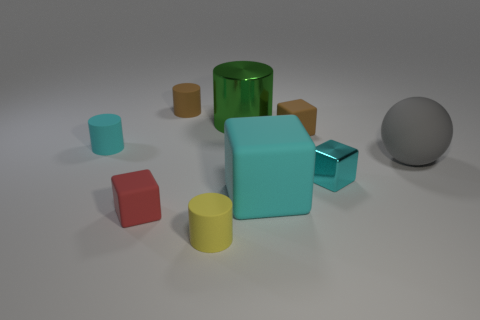Are any metal things visible?
Make the answer very short. Yes. What material is the small cylinder that is the same color as the small metal cube?
Ensure brevity in your answer.  Rubber. What number of objects are either tiny red matte cubes or metallic blocks?
Keep it short and to the point. 2. Is there a metal object that has the same color as the large cylinder?
Ensure brevity in your answer.  No. There is a cyan thing that is behind the ball; how many red blocks are to the left of it?
Ensure brevity in your answer.  0. Is the number of large gray matte spheres greater than the number of tiny brown shiny cylinders?
Give a very brief answer. Yes. Do the brown cylinder and the big green cylinder have the same material?
Provide a succinct answer. No. Are there an equal number of yellow rubber cylinders on the left side of the cyan rubber block and blocks?
Your answer should be compact. No. What number of big balls are made of the same material as the yellow cylinder?
Your response must be concise. 1. Are there fewer large shiny cylinders than big red metallic spheres?
Your answer should be compact. No. 